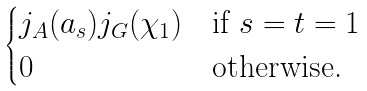<formula> <loc_0><loc_0><loc_500><loc_500>\begin{cases} j _ { A } ( a _ { s } ) j _ { G } ( \chi _ { 1 } ) & \text {if } s = t = 1 \\ 0 & \text {otherwise.} \end{cases}</formula> 